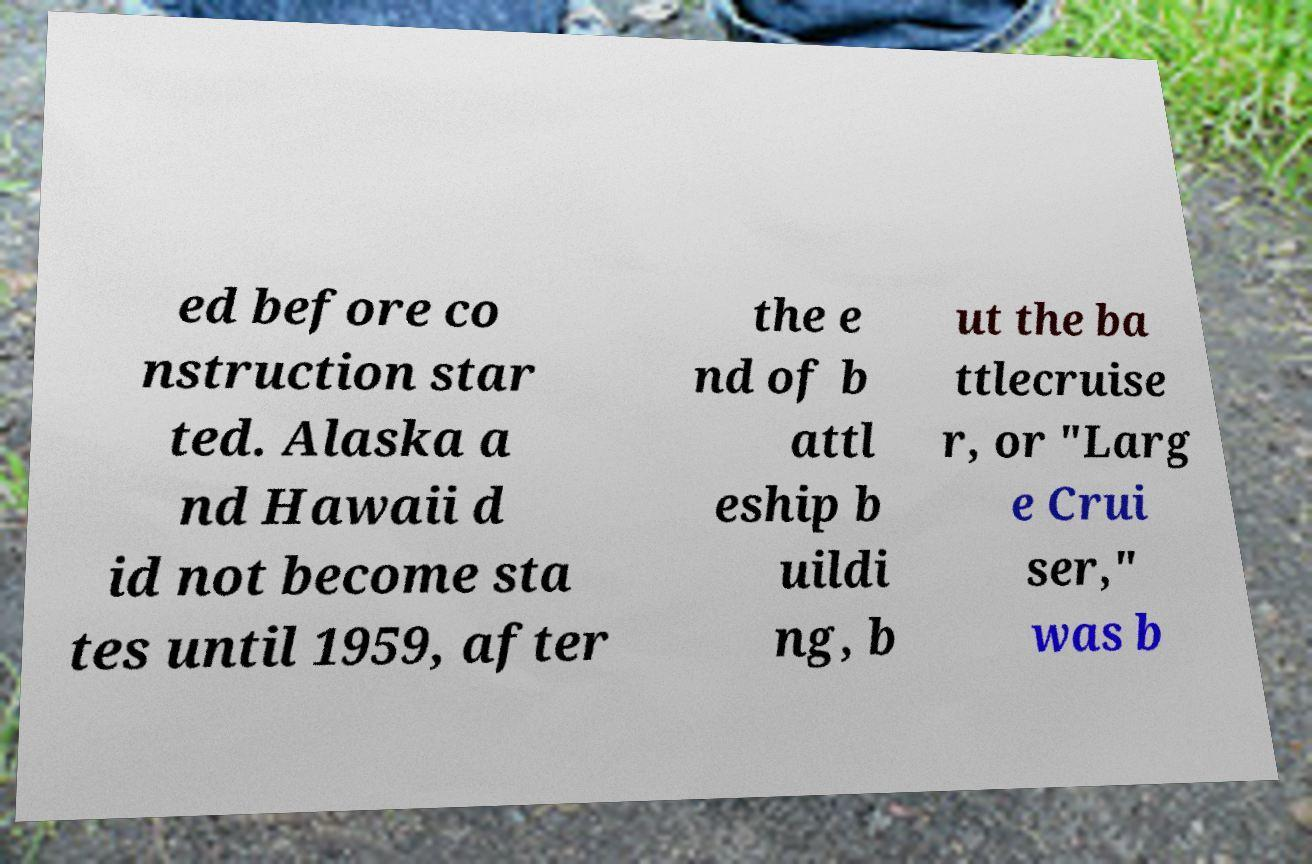Could you extract and type out the text from this image? ed before co nstruction star ted. Alaska a nd Hawaii d id not become sta tes until 1959, after the e nd of b attl eship b uildi ng, b ut the ba ttlecruise r, or "Larg e Crui ser," was b 